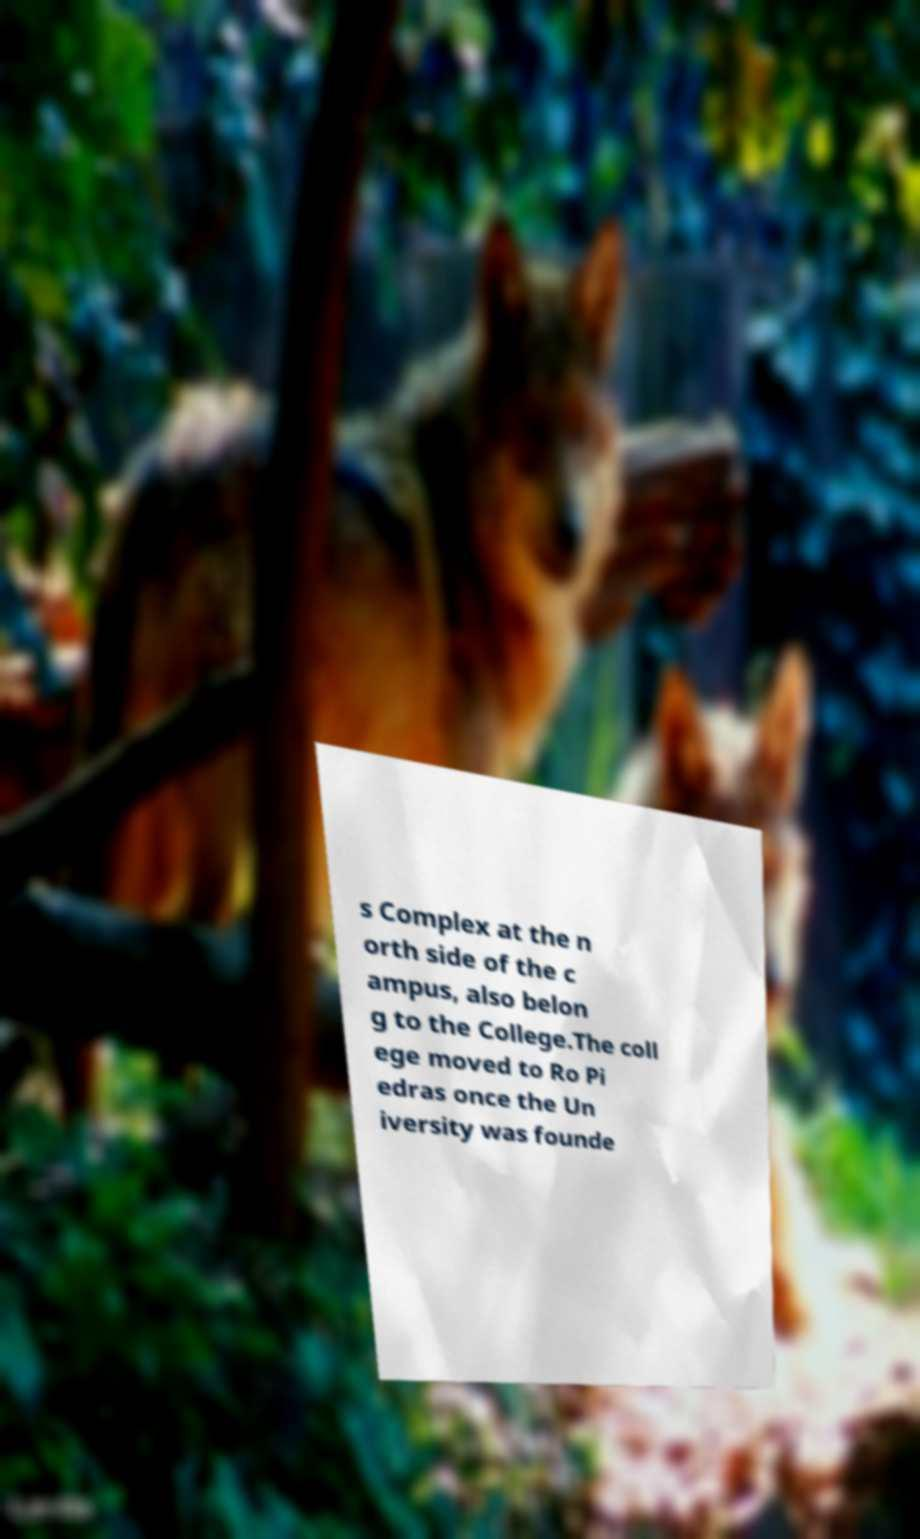Could you extract and type out the text from this image? s Complex at the n orth side of the c ampus, also belon g to the College.The coll ege moved to Ro Pi edras once the Un iversity was founde 